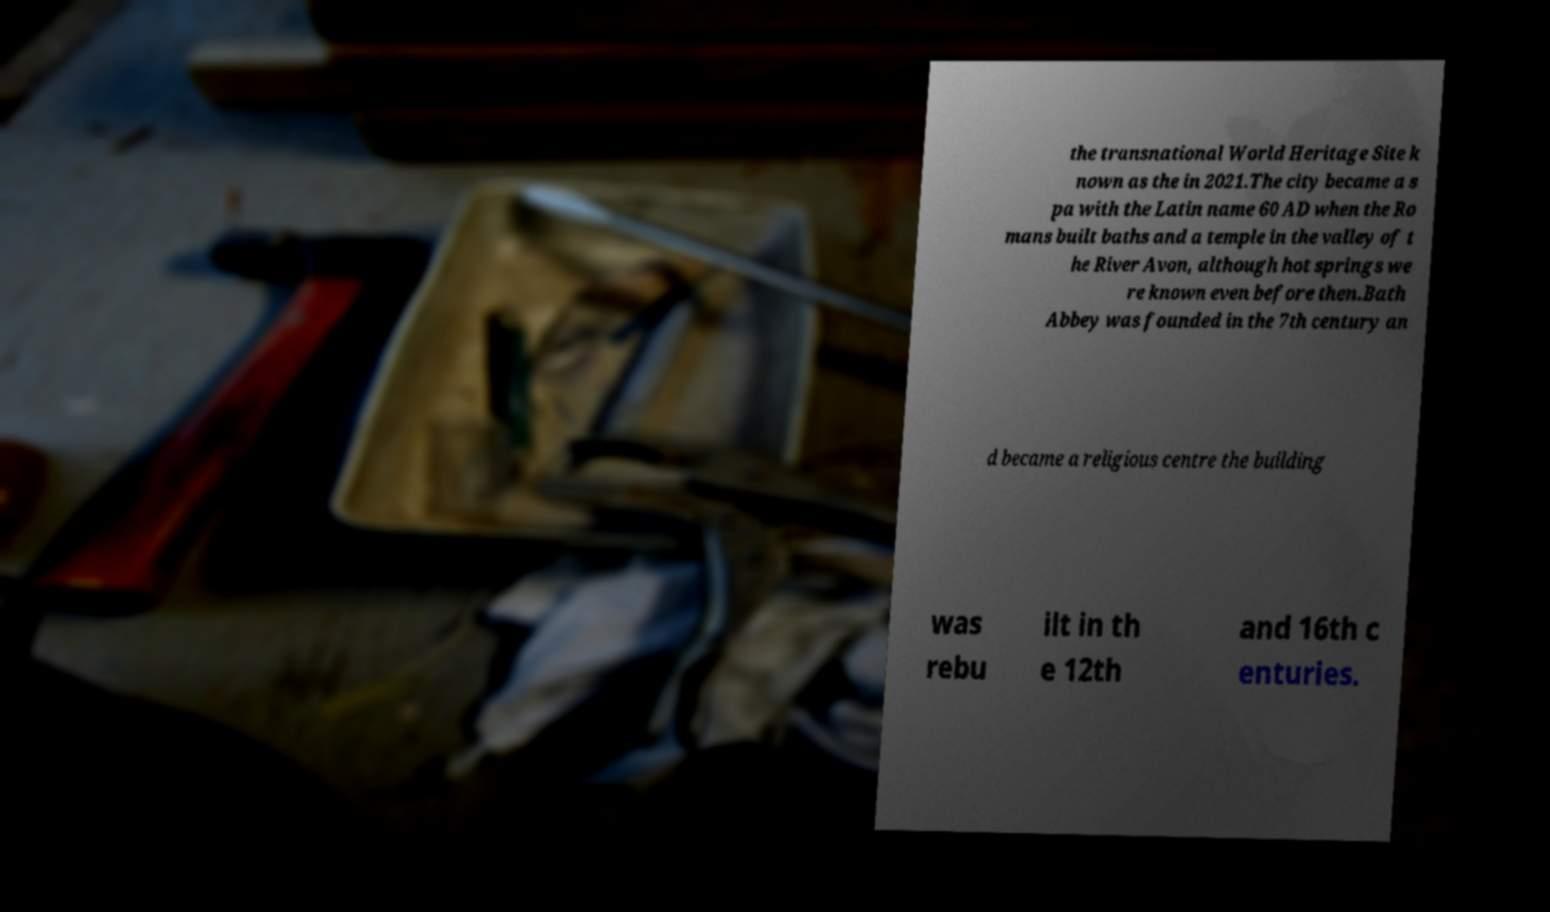Please identify and transcribe the text found in this image. the transnational World Heritage Site k nown as the in 2021.The city became a s pa with the Latin name 60 AD when the Ro mans built baths and a temple in the valley of t he River Avon, although hot springs we re known even before then.Bath Abbey was founded in the 7th century an d became a religious centre the building was rebu ilt in th e 12th and 16th c enturies. 